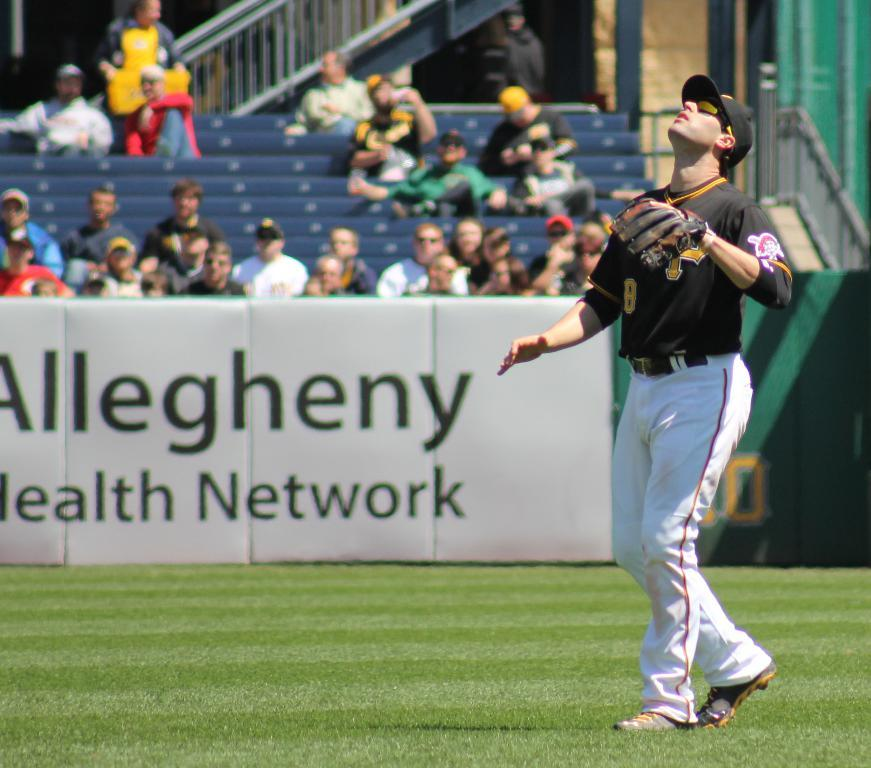<image>
Present a compact description of the photo's key features. A baseball player on a field with an advertisement for a health network. 